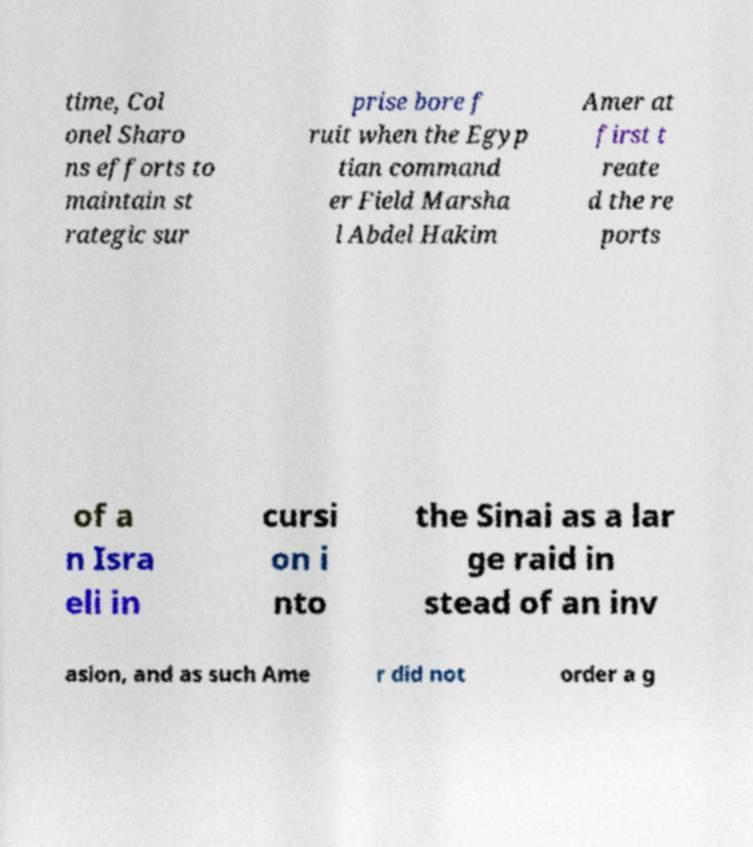Could you assist in decoding the text presented in this image and type it out clearly? time, Col onel Sharo ns efforts to maintain st rategic sur prise bore f ruit when the Egyp tian command er Field Marsha l Abdel Hakim Amer at first t reate d the re ports of a n Isra eli in cursi on i nto the Sinai as a lar ge raid in stead of an inv asion, and as such Ame r did not order a g 